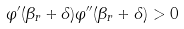Convert formula to latex. <formula><loc_0><loc_0><loc_500><loc_500>\varphi ^ { \prime } ( \beta _ { r } + \delta ) \varphi ^ { \prime \prime } ( \beta _ { r } + \delta ) > 0</formula> 